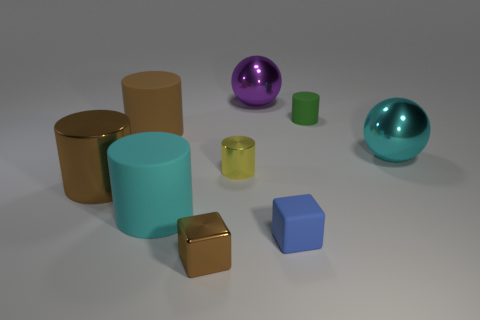Do the big brown cylinder behind the big brown metal object and the tiny yellow cylinder right of the brown block have the same material?
Your answer should be very brief. No. The metal cube has what color?
Provide a short and direct response. Brown. How many cyan rubber things are the same shape as the big brown matte object?
Provide a succinct answer. 1. What color is the shiny sphere that is the same size as the cyan metallic object?
Make the answer very short. Purple. Are any green metallic objects visible?
Your answer should be compact. No. What is the shape of the large cyan object that is to the right of the small brown thing?
Give a very brief answer. Sphere. How many things are in front of the small green rubber cylinder and on the right side of the small blue object?
Keep it short and to the point. 1. Is there a purple sphere made of the same material as the brown cube?
Your response must be concise. Yes. The rubber object that is the same color as the small shiny block is what size?
Your answer should be compact. Large. How many balls are either large brown things or small metallic objects?
Your response must be concise. 0. 